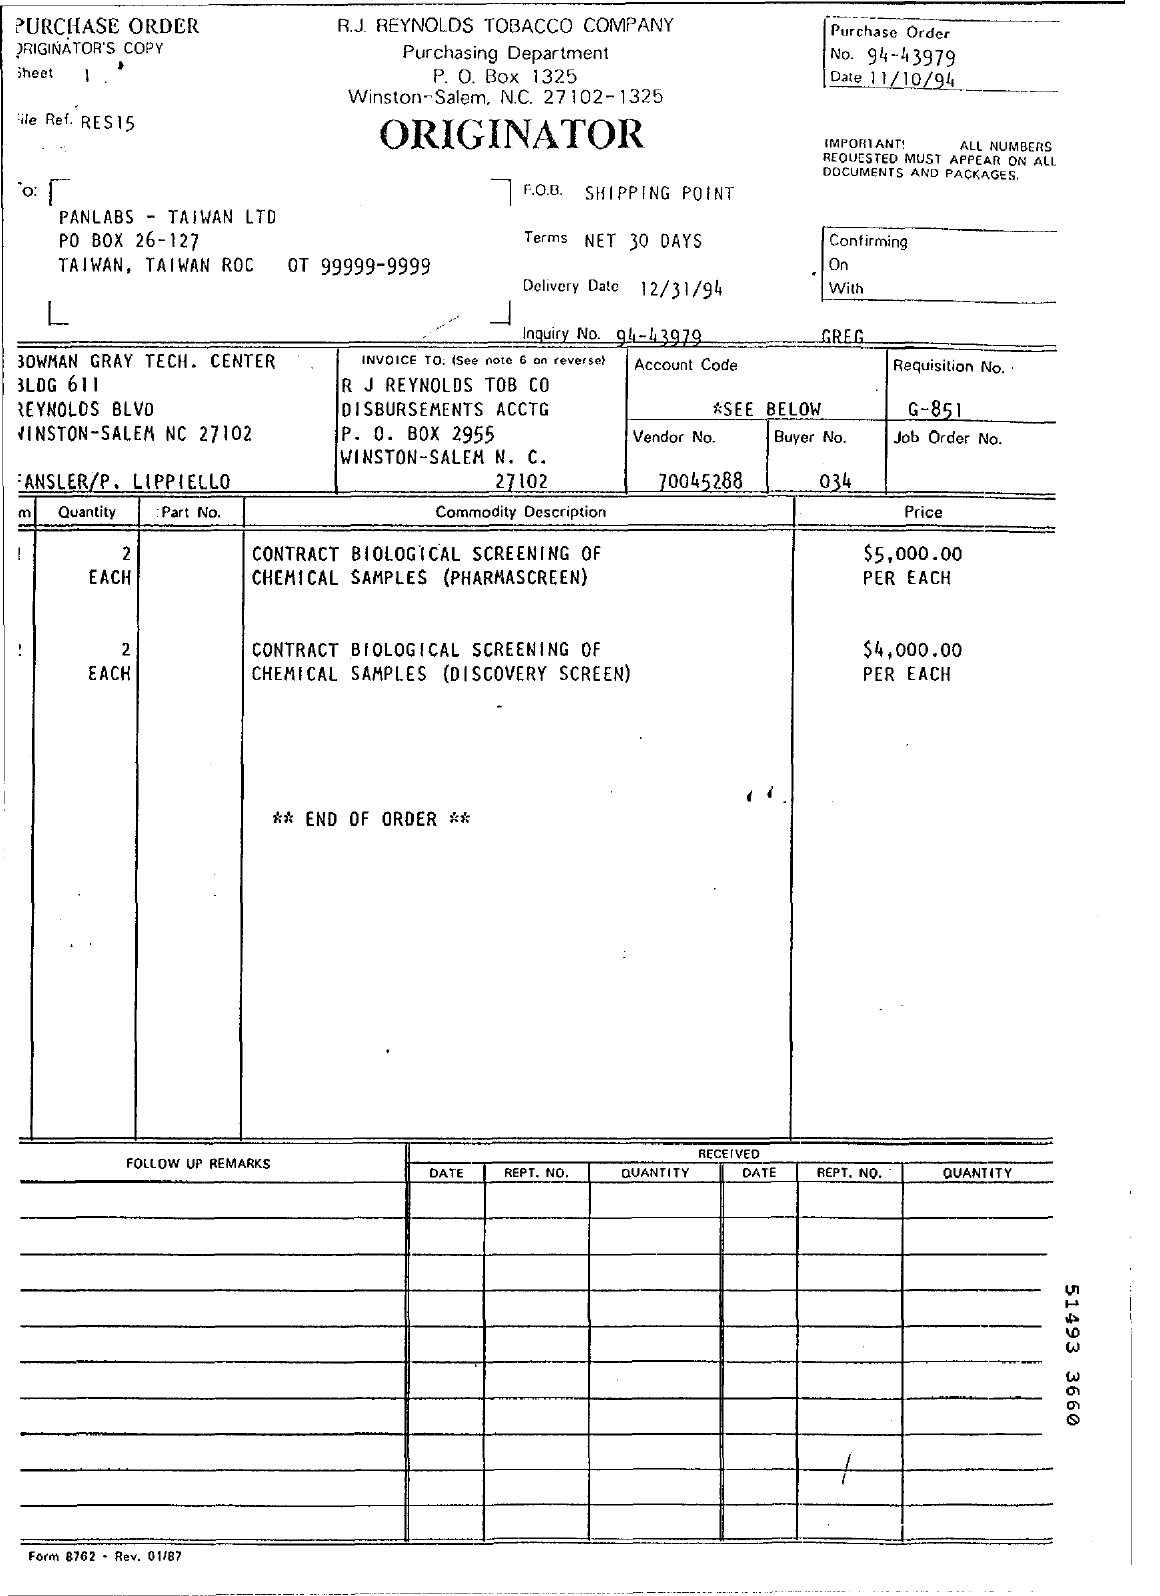Draw attention to some important aspects in this diagram. The buyer number is 034. The date specified at the beginning of the document is 11/10/94. The delivery date is December 31, 1994. The vendor number is 70045288," or "The vendor number is 70045288. The purchase order number is 94-43979. 